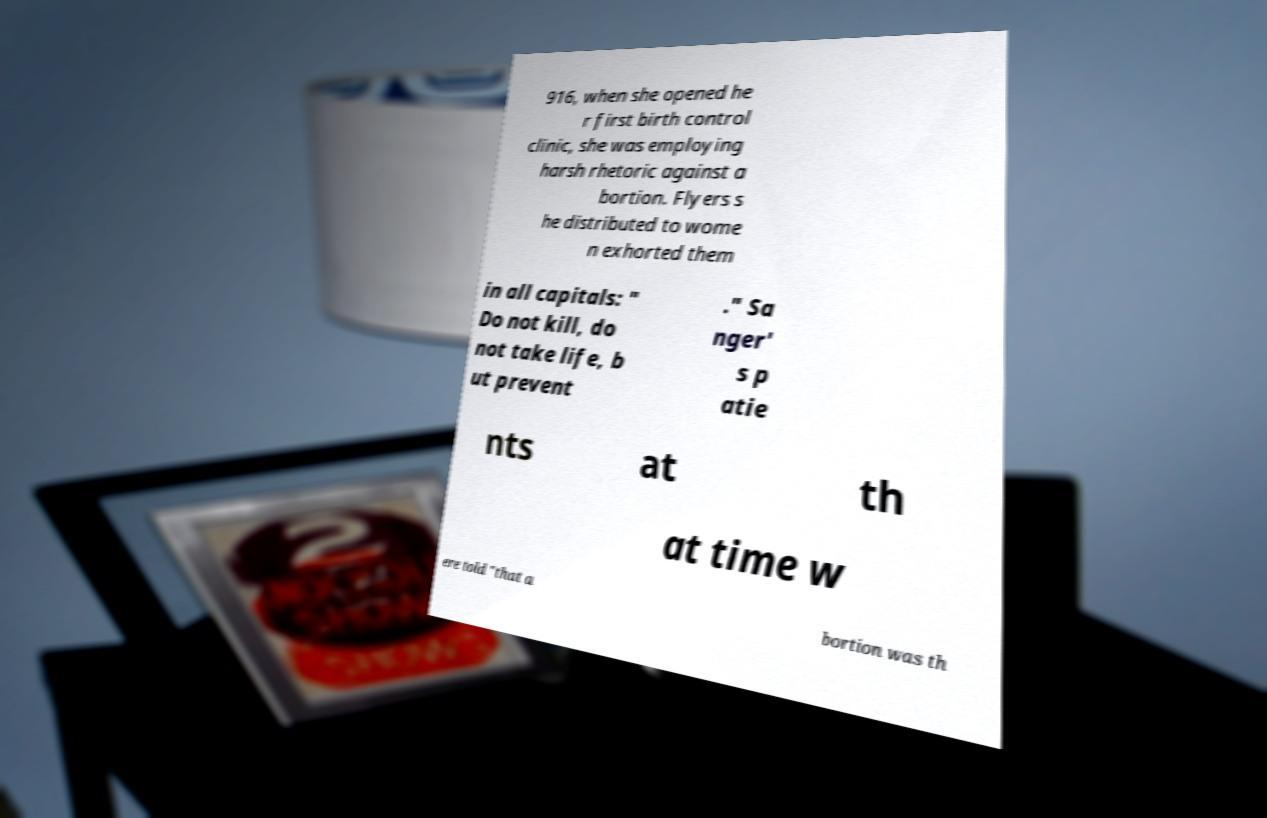What messages or text are displayed in this image? I need them in a readable, typed format. 916, when she opened he r first birth control clinic, she was employing harsh rhetoric against a bortion. Flyers s he distributed to wome n exhorted them in all capitals: " Do not kill, do not take life, b ut prevent ." Sa nger' s p atie nts at th at time w ere told "that a bortion was th 